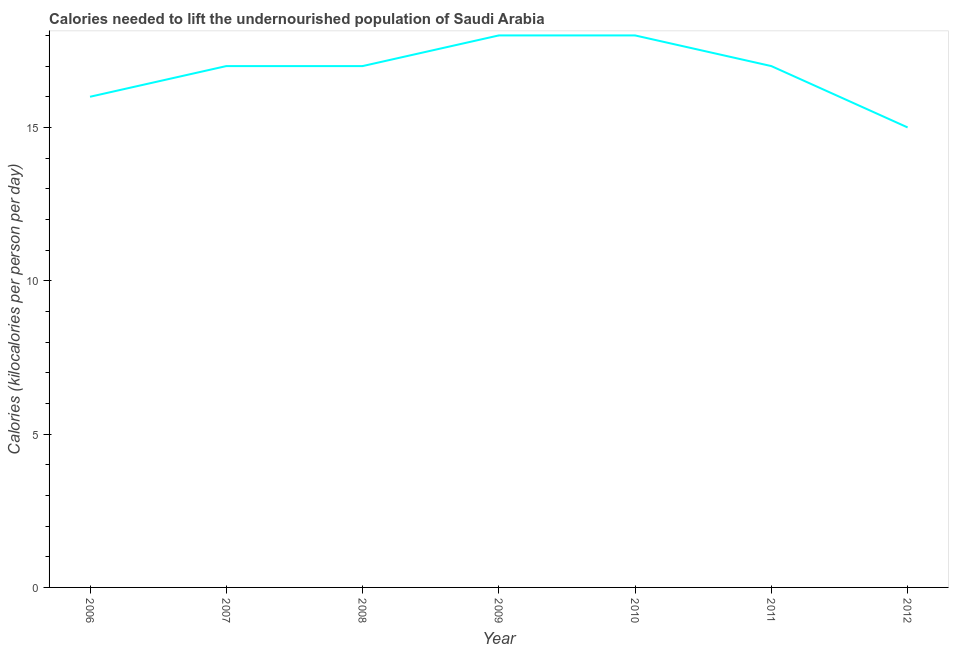What is the depth of food deficit in 2008?
Make the answer very short. 17. Across all years, what is the maximum depth of food deficit?
Your answer should be very brief. 18. Across all years, what is the minimum depth of food deficit?
Your answer should be compact. 15. In which year was the depth of food deficit maximum?
Make the answer very short. 2009. What is the sum of the depth of food deficit?
Offer a very short reply. 118. What is the difference between the depth of food deficit in 2007 and 2009?
Give a very brief answer. -1. What is the average depth of food deficit per year?
Provide a succinct answer. 16.86. In how many years, is the depth of food deficit greater than 11 kilocalories?
Make the answer very short. 7. Do a majority of the years between 2012 and 2008 (inclusive) have depth of food deficit greater than 7 kilocalories?
Ensure brevity in your answer.  Yes. What is the ratio of the depth of food deficit in 2006 to that in 2012?
Your answer should be very brief. 1.07. Is the depth of food deficit in 2006 less than that in 2010?
Ensure brevity in your answer.  Yes. What is the difference between the highest and the second highest depth of food deficit?
Give a very brief answer. 0. What is the difference between the highest and the lowest depth of food deficit?
Your answer should be very brief. 3. In how many years, is the depth of food deficit greater than the average depth of food deficit taken over all years?
Your response must be concise. 5. Does the depth of food deficit monotonically increase over the years?
Make the answer very short. No. How many years are there in the graph?
Provide a short and direct response. 7. Are the values on the major ticks of Y-axis written in scientific E-notation?
Your answer should be very brief. No. Does the graph contain any zero values?
Give a very brief answer. No. What is the title of the graph?
Keep it short and to the point. Calories needed to lift the undernourished population of Saudi Arabia. What is the label or title of the X-axis?
Your answer should be very brief. Year. What is the label or title of the Y-axis?
Ensure brevity in your answer.  Calories (kilocalories per person per day). What is the Calories (kilocalories per person per day) of 2009?
Your answer should be very brief. 18. What is the Calories (kilocalories per person per day) of 2010?
Your answer should be compact. 18. What is the Calories (kilocalories per person per day) in 2012?
Give a very brief answer. 15. What is the difference between the Calories (kilocalories per person per day) in 2006 and 2007?
Ensure brevity in your answer.  -1. What is the difference between the Calories (kilocalories per person per day) in 2006 and 2009?
Provide a succinct answer. -2. What is the difference between the Calories (kilocalories per person per day) in 2006 and 2012?
Keep it short and to the point. 1. What is the difference between the Calories (kilocalories per person per day) in 2007 and 2009?
Offer a very short reply. -1. What is the difference between the Calories (kilocalories per person per day) in 2007 and 2010?
Give a very brief answer. -1. What is the difference between the Calories (kilocalories per person per day) in 2007 and 2011?
Give a very brief answer. 0. What is the difference between the Calories (kilocalories per person per day) in 2007 and 2012?
Your response must be concise. 2. What is the difference between the Calories (kilocalories per person per day) in 2008 and 2009?
Make the answer very short. -1. What is the difference between the Calories (kilocalories per person per day) in 2008 and 2012?
Give a very brief answer. 2. What is the difference between the Calories (kilocalories per person per day) in 2009 and 2010?
Ensure brevity in your answer.  0. What is the difference between the Calories (kilocalories per person per day) in 2009 and 2011?
Give a very brief answer. 1. What is the difference between the Calories (kilocalories per person per day) in 2010 and 2011?
Provide a short and direct response. 1. What is the difference between the Calories (kilocalories per person per day) in 2010 and 2012?
Your answer should be compact. 3. What is the ratio of the Calories (kilocalories per person per day) in 2006 to that in 2007?
Provide a short and direct response. 0.94. What is the ratio of the Calories (kilocalories per person per day) in 2006 to that in 2008?
Your response must be concise. 0.94. What is the ratio of the Calories (kilocalories per person per day) in 2006 to that in 2009?
Ensure brevity in your answer.  0.89. What is the ratio of the Calories (kilocalories per person per day) in 2006 to that in 2010?
Your answer should be compact. 0.89. What is the ratio of the Calories (kilocalories per person per day) in 2006 to that in 2011?
Provide a short and direct response. 0.94. What is the ratio of the Calories (kilocalories per person per day) in 2006 to that in 2012?
Offer a very short reply. 1.07. What is the ratio of the Calories (kilocalories per person per day) in 2007 to that in 2008?
Make the answer very short. 1. What is the ratio of the Calories (kilocalories per person per day) in 2007 to that in 2009?
Provide a succinct answer. 0.94. What is the ratio of the Calories (kilocalories per person per day) in 2007 to that in 2010?
Make the answer very short. 0.94. What is the ratio of the Calories (kilocalories per person per day) in 2007 to that in 2012?
Make the answer very short. 1.13. What is the ratio of the Calories (kilocalories per person per day) in 2008 to that in 2009?
Give a very brief answer. 0.94. What is the ratio of the Calories (kilocalories per person per day) in 2008 to that in 2010?
Provide a succinct answer. 0.94. What is the ratio of the Calories (kilocalories per person per day) in 2008 to that in 2011?
Your answer should be compact. 1. What is the ratio of the Calories (kilocalories per person per day) in 2008 to that in 2012?
Offer a very short reply. 1.13. What is the ratio of the Calories (kilocalories per person per day) in 2009 to that in 2010?
Make the answer very short. 1. What is the ratio of the Calories (kilocalories per person per day) in 2009 to that in 2011?
Offer a very short reply. 1.06. What is the ratio of the Calories (kilocalories per person per day) in 2010 to that in 2011?
Make the answer very short. 1.06. What is the ratio of the Calories (kilocalories per person per day) in 2010 to that in 2012?
Keep it short and to the point. 1.2. What is the ratio of the Calories (kilocalories per person per day) in 2011 to that in 2012?
Your answer should be very brief. 1.13. 